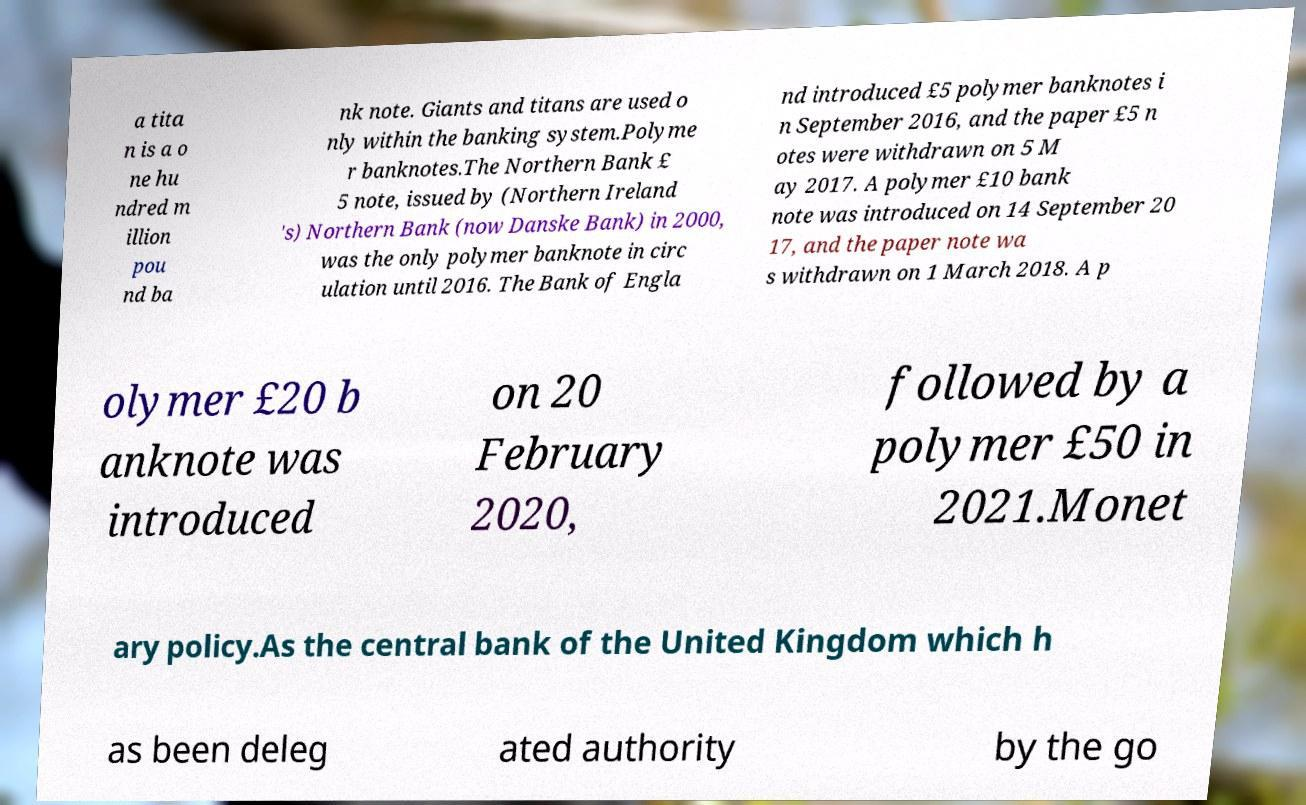Could you assist in decoding the text presented in this image and type it out clearly? a tita n is a o ne hu ndred m illion pou nd ba nk note. Giants and titans are used o nly within the banking system.Polyme r banknotes.The Northern Bank £ 5 note, issued by (Northern Ireland 's) Northern Bank (now Danske Bank) in 2000, was the only polymer banknote in circ ulation until 2016. The Bank of Engla nd introduced £5 polymer banknotes i n September 2016, and the paper £5 n otes were withdrawn on 5 M ay 2017. A polymer £10 bank note was introduced on 14 September 20 17, and the paper note wa s withdrawn on 1 March 2018. A p olymer £20 b anknote was introduced on 20 February 2020, followed by a polymer £50 in 2021.Monet ary policy.As the central bank of the United Kingdom which h as been deleg ated authority by the go 